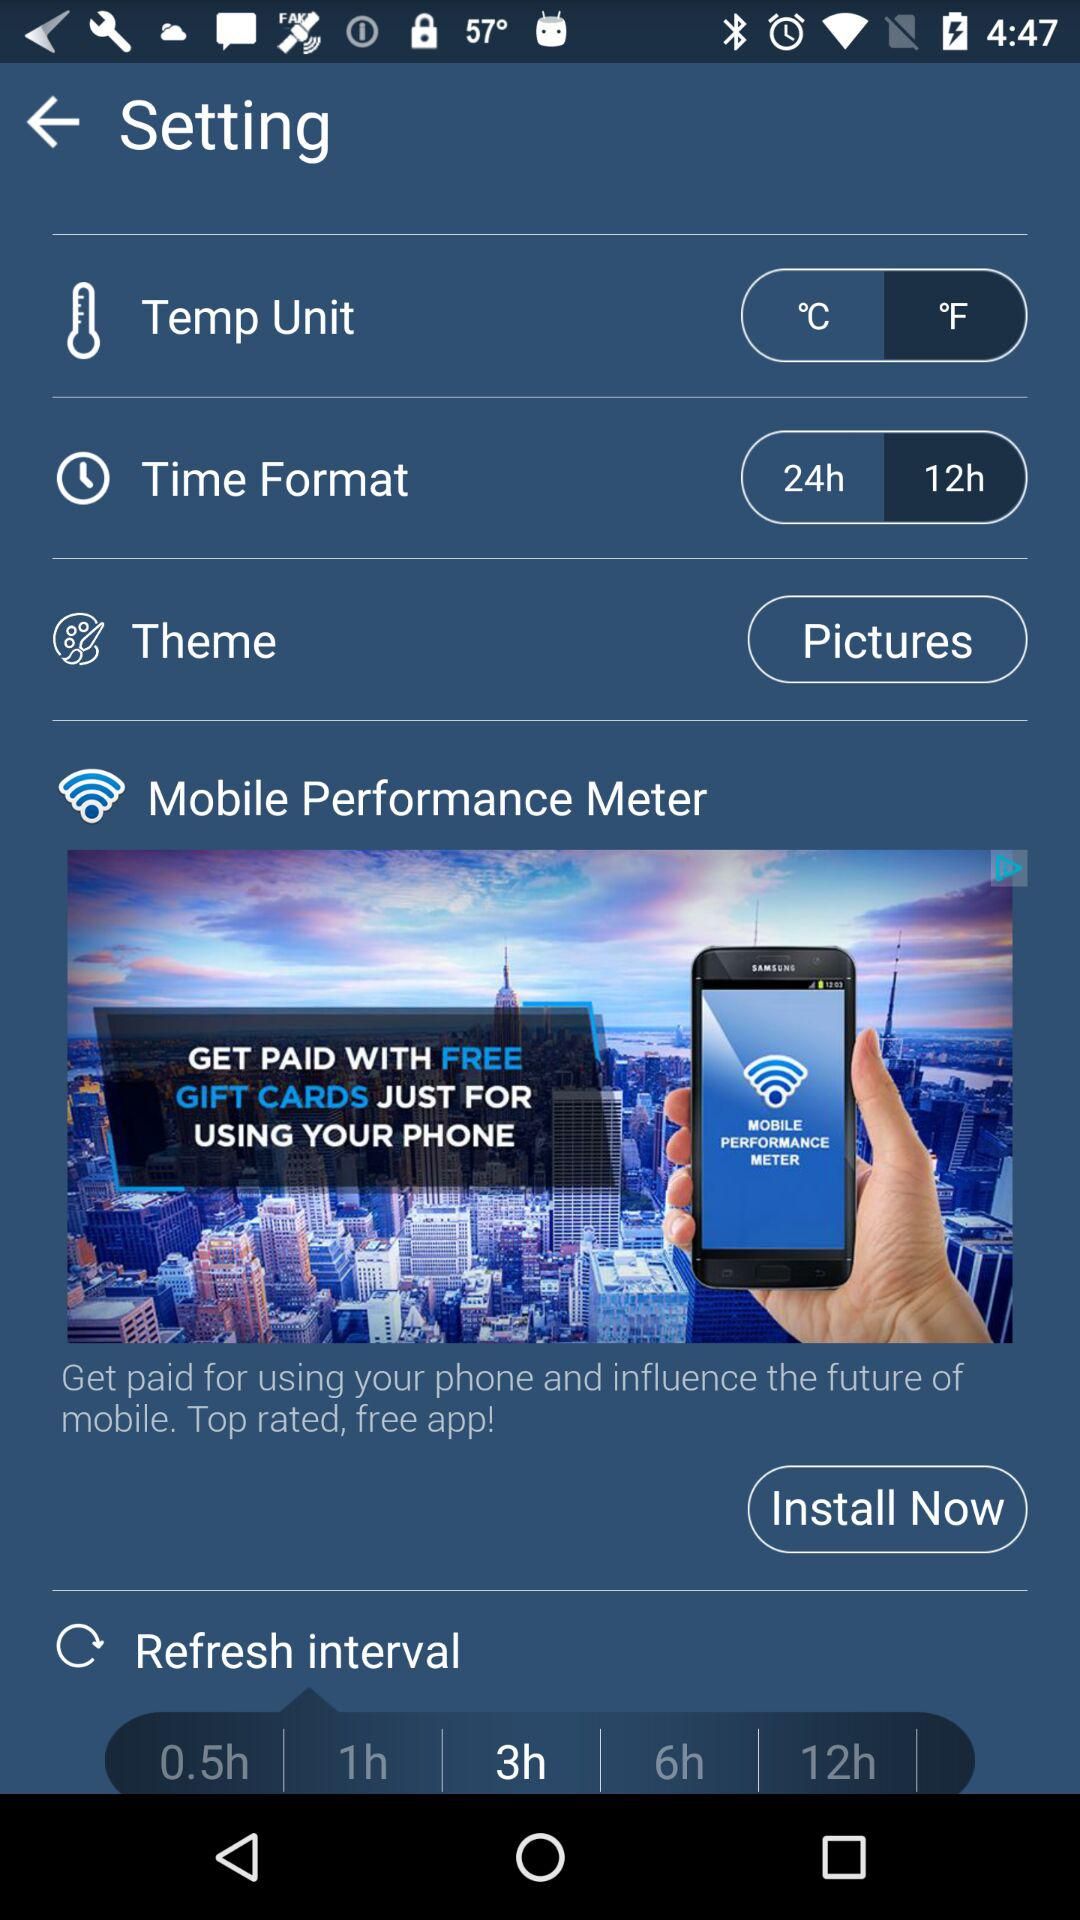What is the selected temperature unit? The selected temperature unit is °F. 